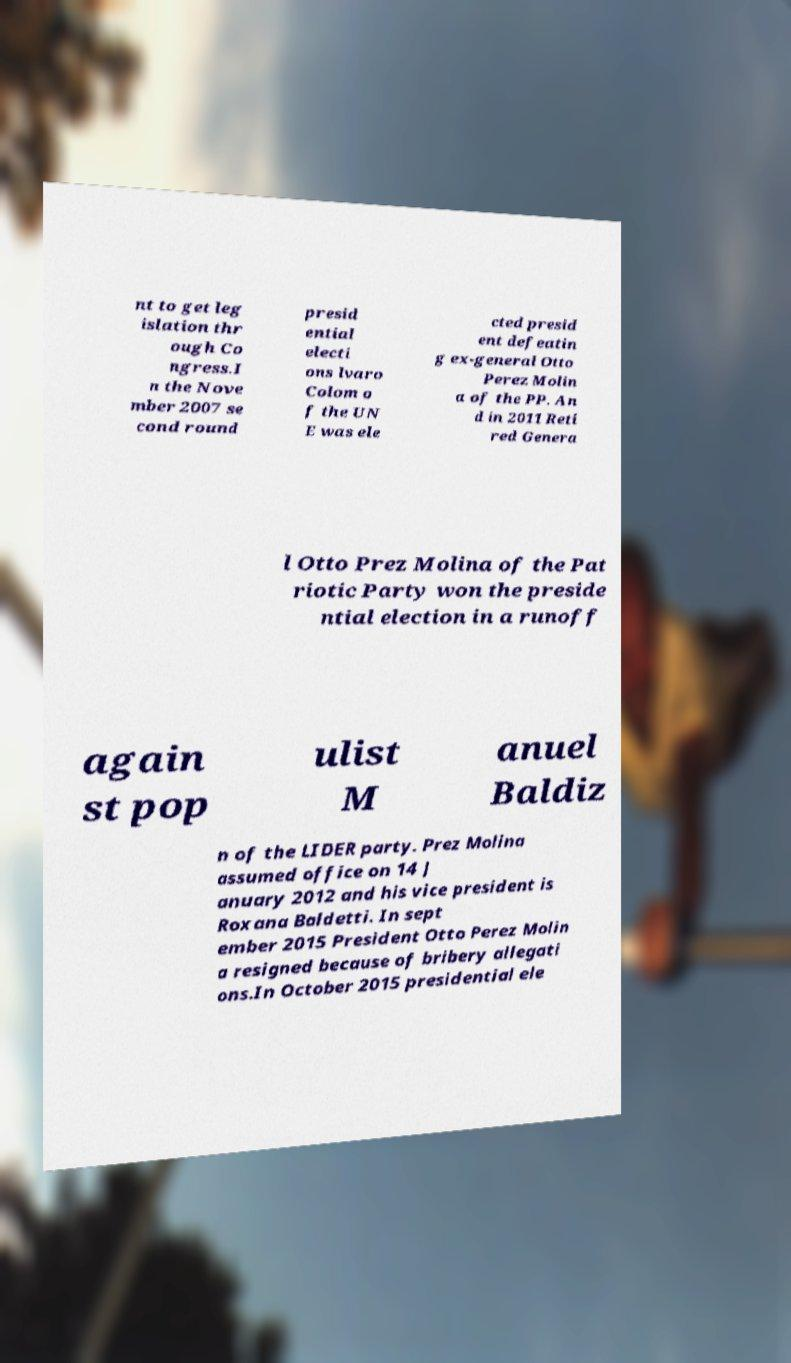For documentation purposes, I need the text within this image transcribed. Could you provide that? nt to get leg islation thr ough Co ngress.I n the Nove mber 2007 se cond round presid ential electi ons lvaro Colom o f the UN E was ele cted presid ent defeatin g ex-general Otto Perez Molin a of the PP. An d in 2011 Reti red Genera l Otto Prez Molina of the Pat riotic Party won the preside ntial election in a runoff again st pop ulist M anuel Baldiz n of the LIDER party. Prez Molina assumed office on 14 J anuary 2012 and his vice president is Roxana Baldetti. In sept ember 2015 President Otto Perez Molin a resigned because of bribery allegati ons.In October 2015 presidential ele 